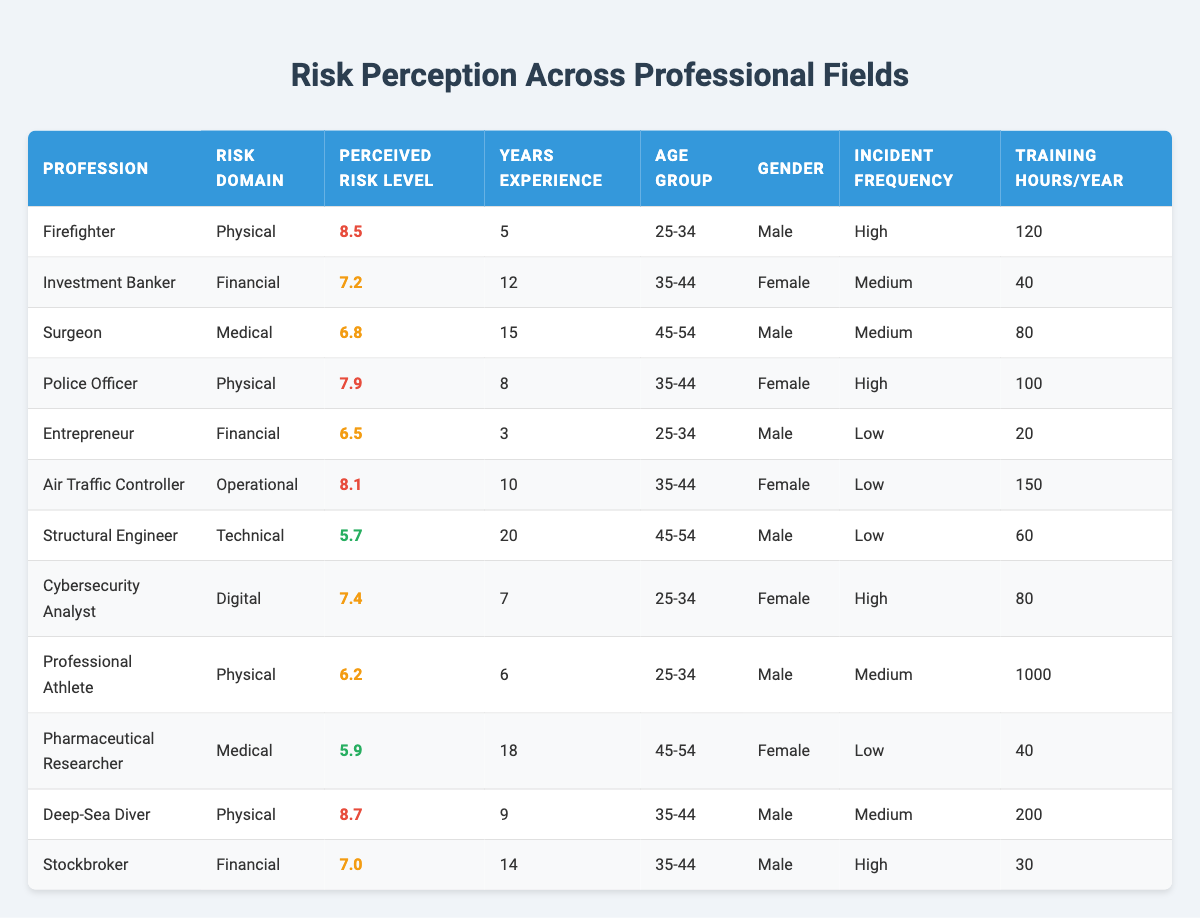What is the perceived risk level of a Firefighter? The table indicates that the perceived risk level for a Firefighter is 8.5.
Answer: 8.5 Which profession has the highest perceived risk level? Among the listed professions, the Deep-Sea Diver has the highest perceived risk level of 8.7.
Answer: Deep-Sea Diver Is the majority of the professionals in the table male? There are 7 males and 5 females in the table, thus the majority of professionals are male.
Answer: Yes What is the average perceived risk level for all the Physical risk domain professions? The perceived risk levels for Physical risk domain are: Firefighter (8.5), Police Officer (7.9), Professional Athlete (6.2), and Deep-Sea Diver (8.7). Summing them gives 31.3 and dividing by 4 gives an average of 7.825.
Answer: 7.825 How many training hours per year does a Cybersecurity Analyst have? The table shows that a Cybersecurity Analyst has 80 training hours per year.
Answer: 80 What is the training hours per year for the profession with the lowest perceived risk level? The profession with the lowest perceived risk level is Structural Engineer (5.7), which has 60 training hours per year.
Answer: 60 Is it true that all professionals in the Financial risk domain have a perceived risk level of 7 or higher? The perceived risk levels for the Financial domain are: Investment Banker (7.2), Entrepreneur (6.5), and Stockbroker (7.0). Since Entrepreneur has 6.5 which is below 7, the statement is false.
Answer: No What is the perceived risk level of Surgeons compared to Police Officers? Surgeons have a perceived risk level of 6.8 while Police Officers have a level of 7.9. Comparing these values shows that Police Officers have a higher perceived risk level.
Answer: Police Officers Which gender has a higher average perceived risk level among all the professions listed? To find out, the average for males (8.5 + 6.8 + 7.9 + 6.2 + 8.7 + 7.0 = 45.8, divided by 6) is 7.633. For females (7.2 + 7.4 + 5.9 + 8.1 = 28.6, divided by 4) is 7.15. Males have a higher average perceived risk level.
Answer: Males 